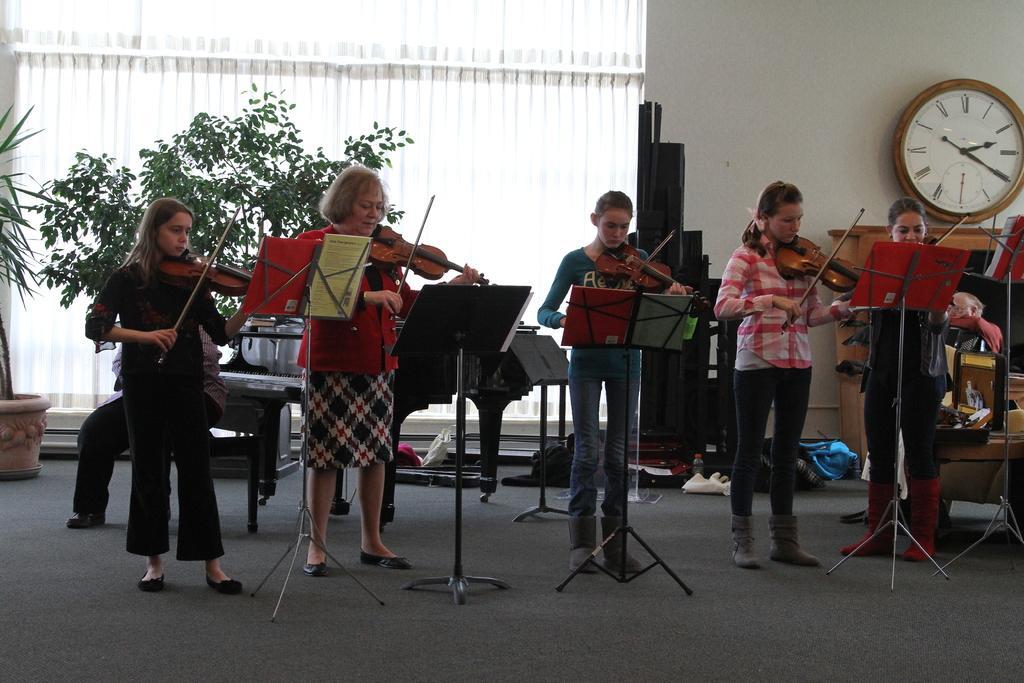Please provide a concise description of this image. This picture shows a group of people playing violin and we see few book stands in front of them and we see a wall clock on the wall and couple of plants 